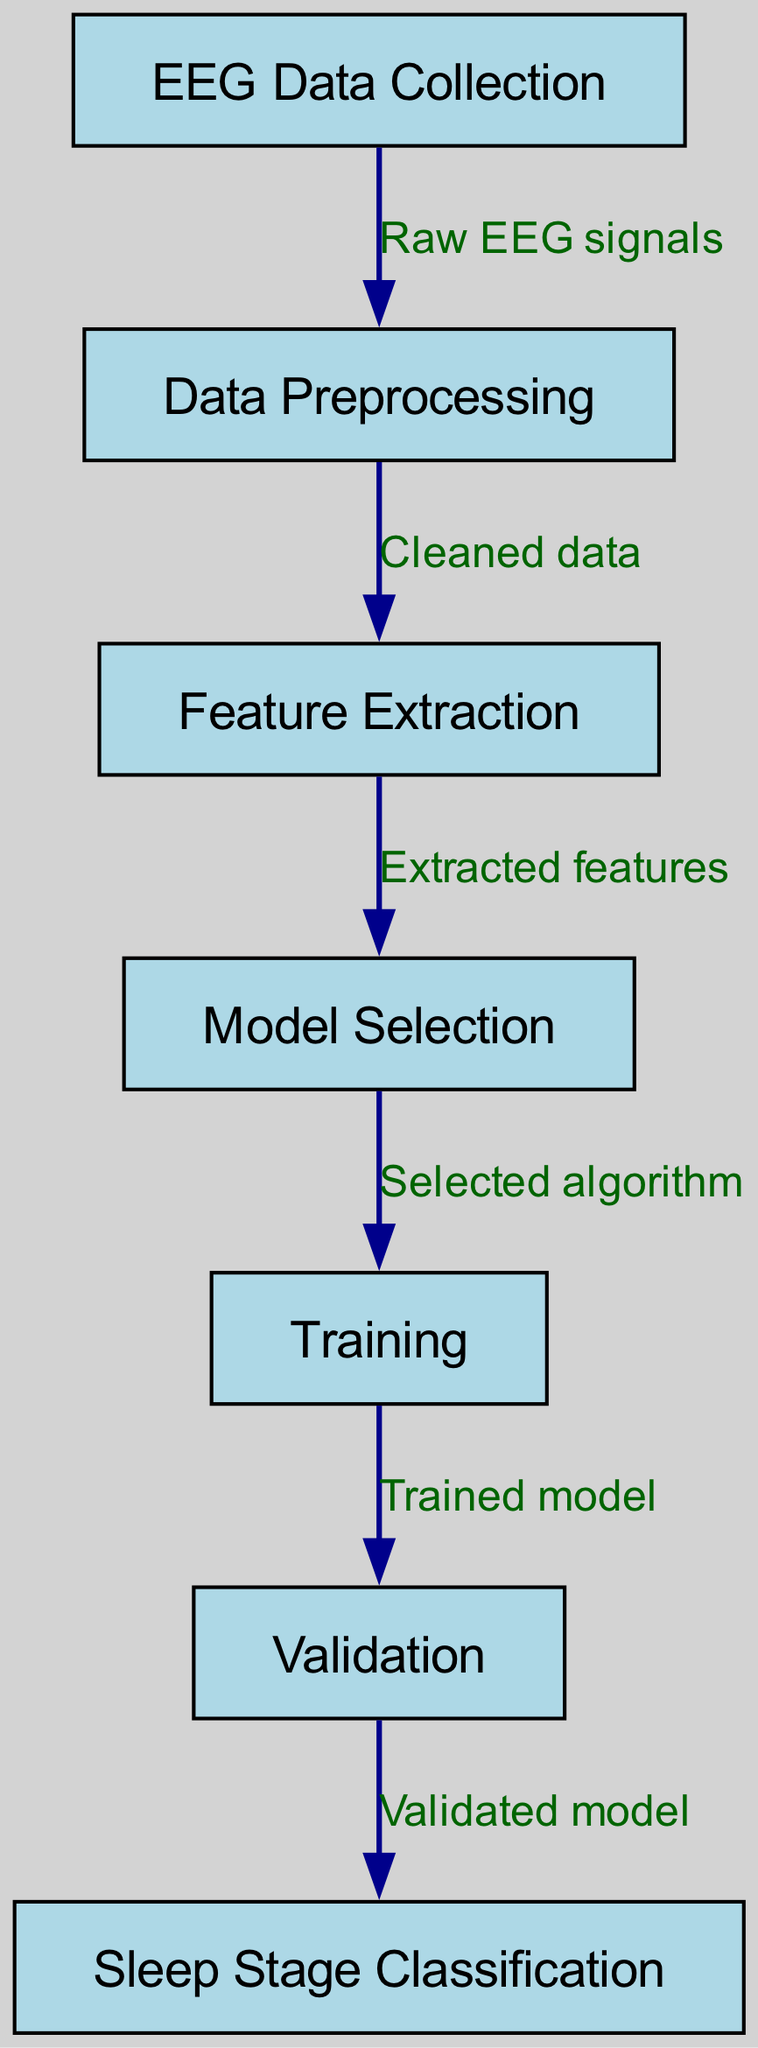What is the first step in the machine learning process? The first node in the flowchart is "EEG Data Collection," indicating that collecting EEG data is the initial step of the process.
Answer: EEG Data Collection How many nodes are present in the diagram? The diagram outlines a total of seven nodes, as indicated by the nodes listed in the data structure.
Answer: 7 What type of data is processed after EEG Data Collection? The process moves from "EEG Data Collection" to "Data Preprocessing," which involves handling the raw EEG signals collected.
Answer: Raw EEG signals Which step comes directly after Feature Extraction? The flowchart shows that after "Feature Extraction," the next step is "Model Selection," indicating the progression in the machine learning pipeline.
Answer: Model Selection What is the final outcome of the process illustrated in the diagram? The last node in the flowchart is "Sleep Stage Classification," which represents the final result of the machine learning process.
Answer: Sleep Stage Classification Which two nodes are connected by the edge labeled "Cleaned data"? The edge labeled "Cleaned data" connects the nodes "Data Preprocessing" and "Feature Extraction," indicating the data cleaning step is crucial for feature extraction.
Answer: Data Preprocessing and Feature Extraction How does the model in the Training stage relate to the Validation stage? The flowchart indicates that the model transitions from "Training" to "Validation," signifying that a trained model is subsequently validated to ensure its accuracy.
Answer: Validated model What represents the transition between Model Selection and Training? The edge between "Model Selection" and "Training" is labeled "Selected algorithm," which signifies that the chosen model is then used for training.
Answer: Selected algorithm 